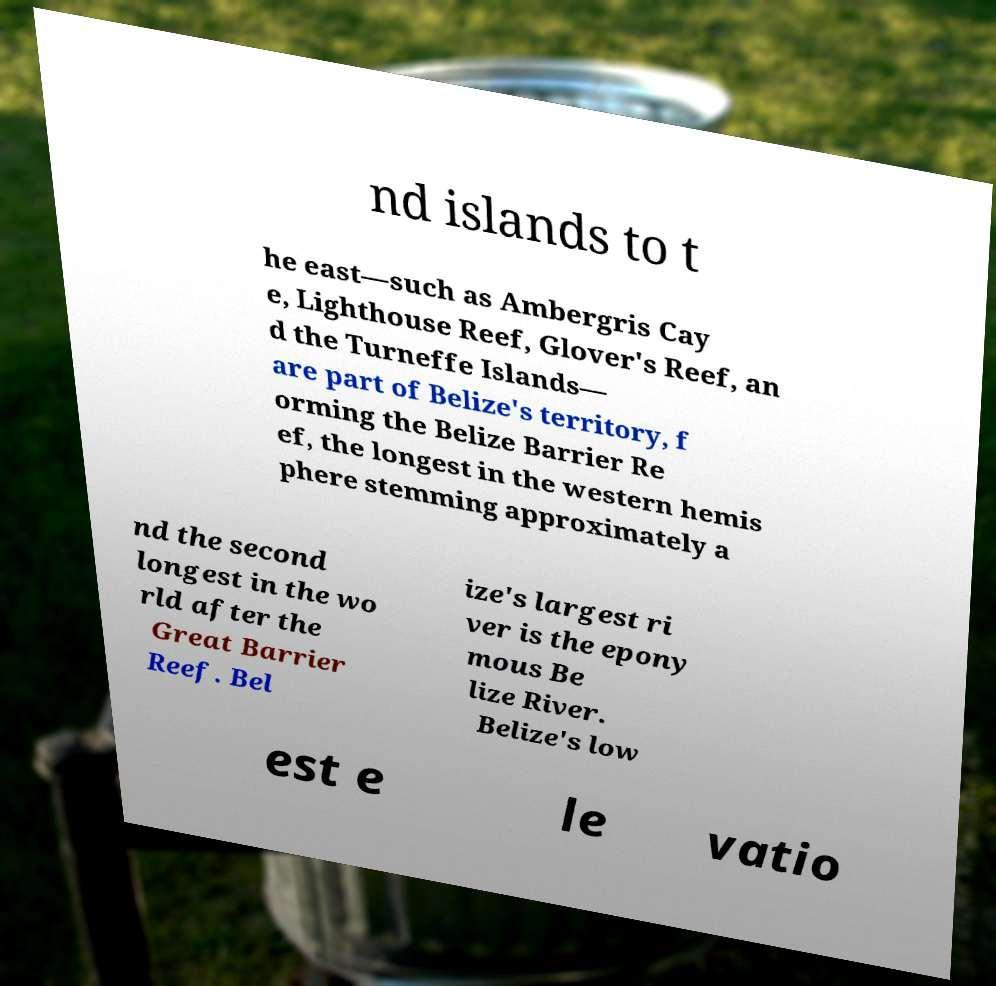Please identify and transcribe the text found in this image. nd islands to t he east—such as Ambergris Cay e, Lighthouse Reef, Glover's Reef, an d the Turneffe Islands— are part of Belize's territory, f orming the Belize Barrier Re ef, the longest in the western hemis phere stemming approximately a nd the second longest in the wo rld after the Great Barrier Reef. Bel ize's largest ri ver is the epony mous Be lize River. Belize's low est e le vatio 